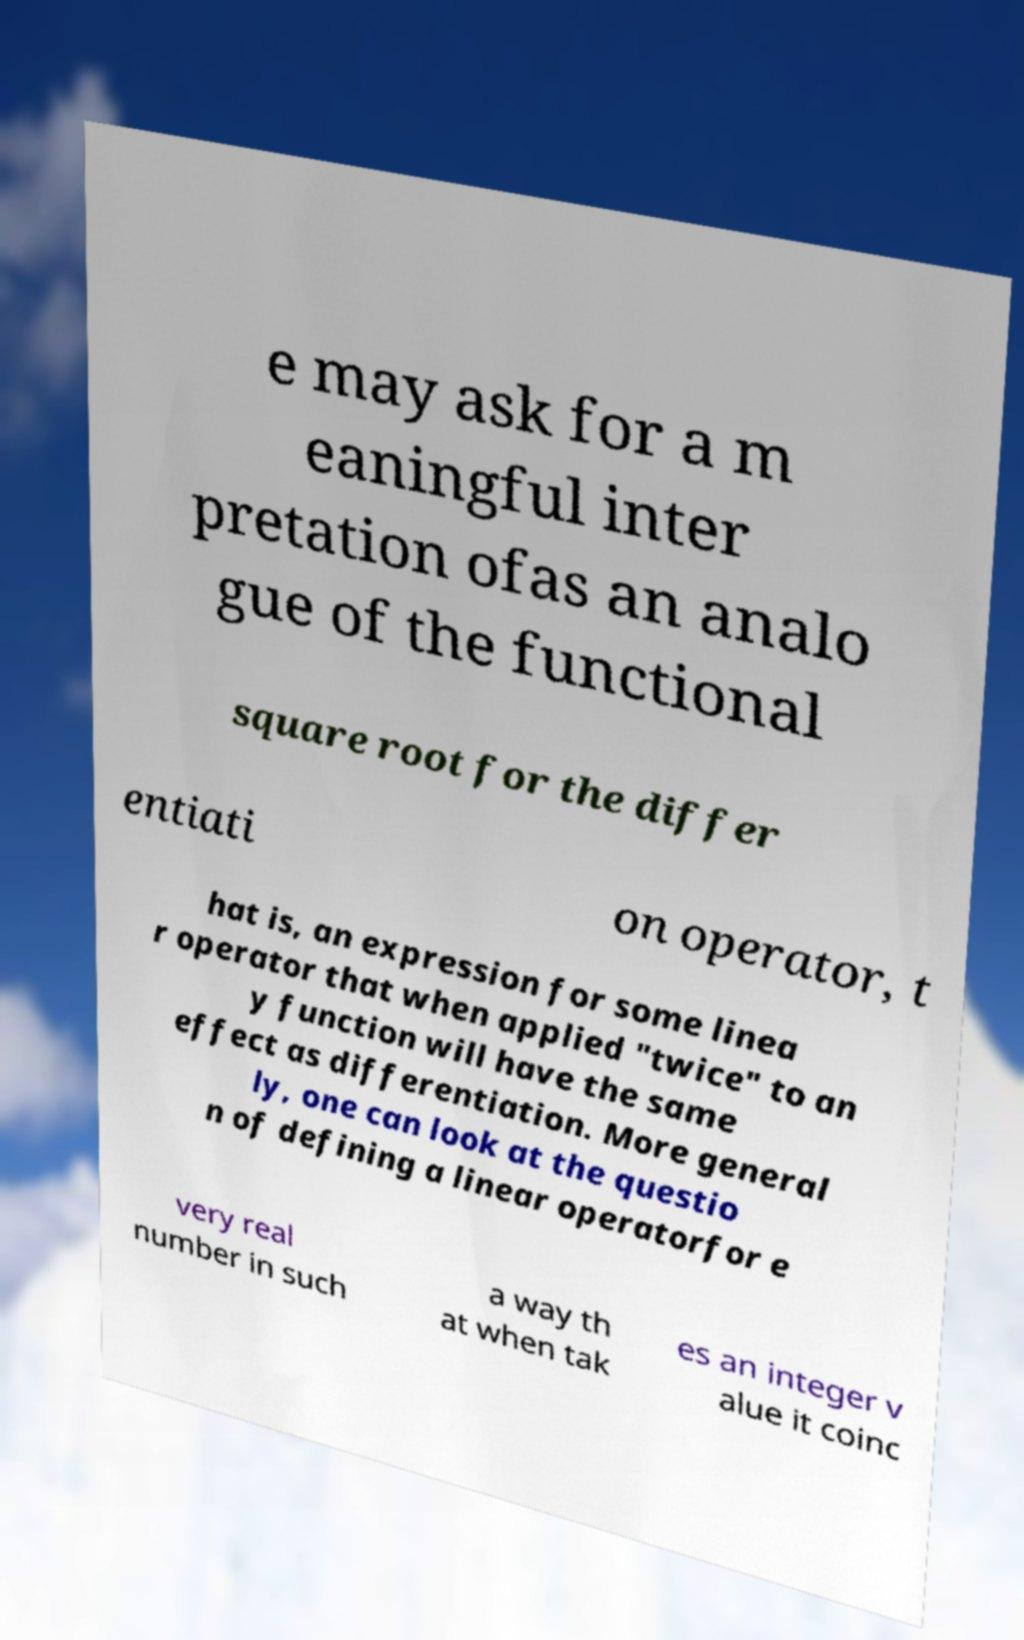I need the written content from this picture converted into text. Can you do that? e may ask for a m eaningful inter pretation ofas an analo gue of the functional square root for the differ entiati on operator, t hat is, an expression for some linea r operator that when applied "twice" to an y function will have the same effect as differentiation. More general ly, one can look at the questio n of defining a linear operatorfor e very real number in such a way th at when tak es an integer v alue it coinc 